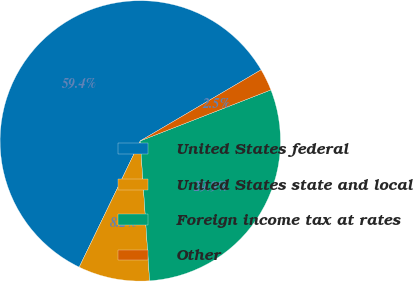Convert chart. <chart><loc_0><loc_0><loc_500><loc_500><pie_chart><fcel>United States federal<fcel>United States state and local<fcel>Foreign income tax at rates<fcel>Other<nl><fcel>59.37%<fcel>8.23%<fcel>29.86%<fcel>2.54%<nl></chart> 